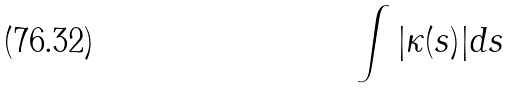<formula> <loc_0><loc_0><loc_500><loc_500>\int | \kappa ( s ) | d s</formula> 